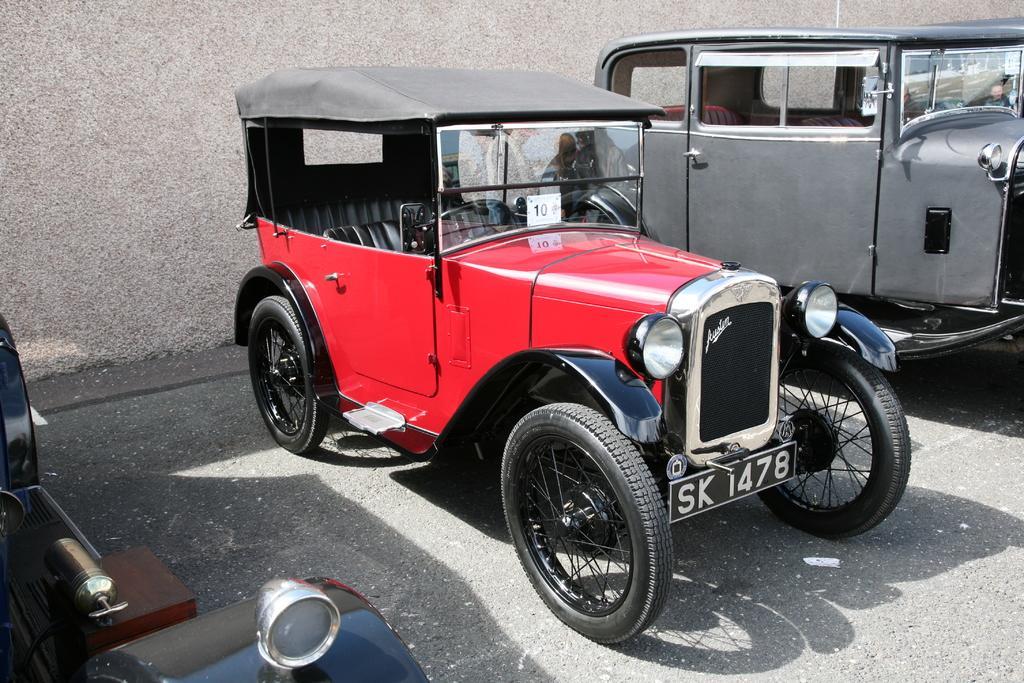How would you summarize this image in a sentence or two? In this image I can see three vehicles and I can also see shadows on the road. In the background I can see the wall. In the centre of this image I can see a white colour board on the vehicle's windshield and on the board I can see something is written. 